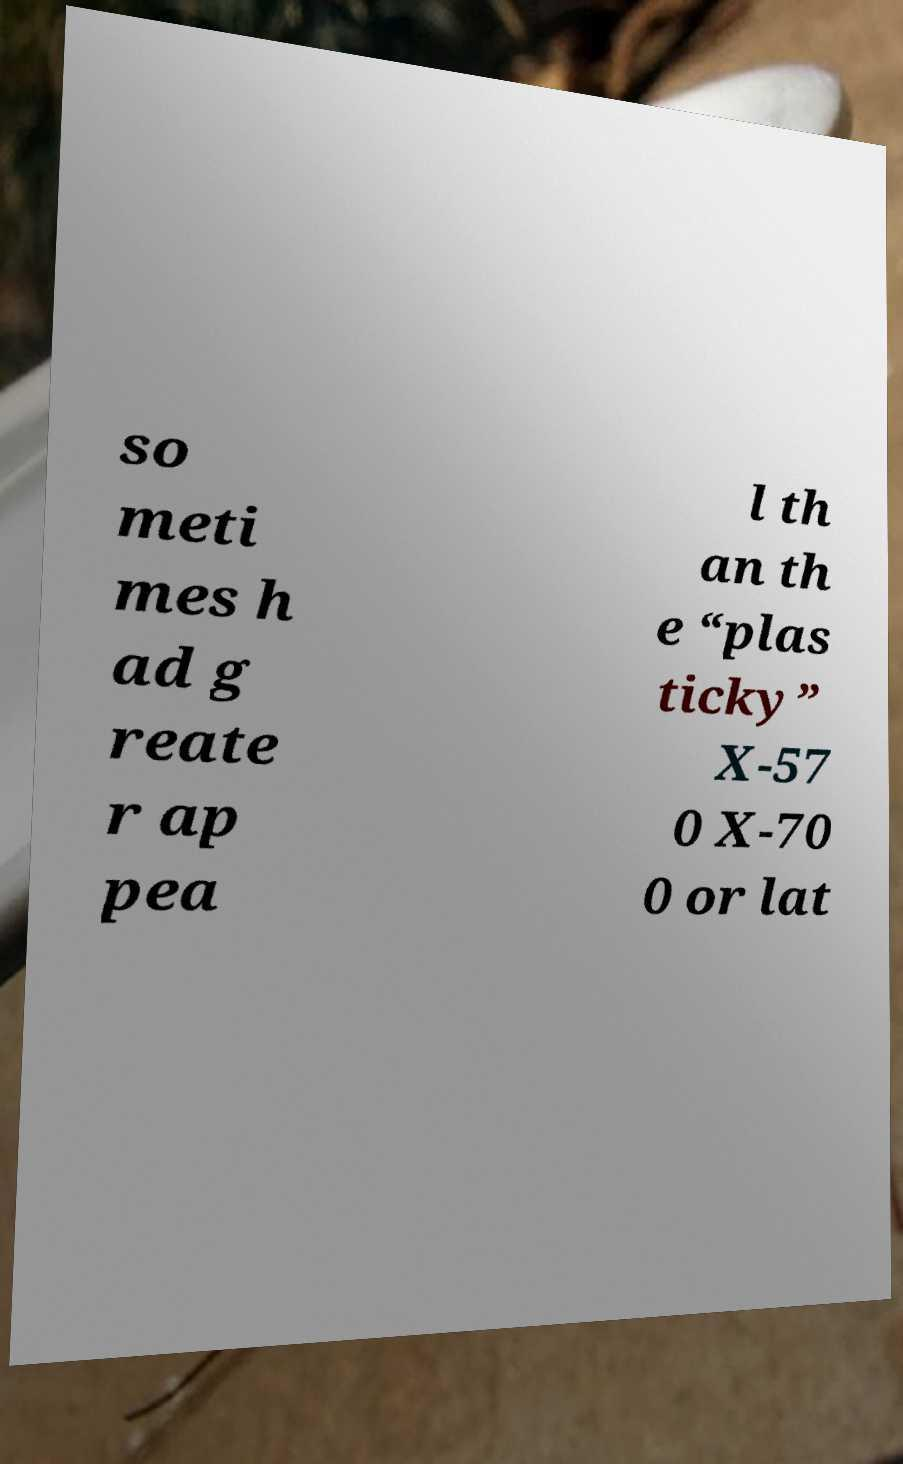Could you assist in decoding the text presented in this image and type it out clearly? so meti mes h ad g reate r ap pea l th an th e “plas ticky” X-57 0 X-70 0 or lat 